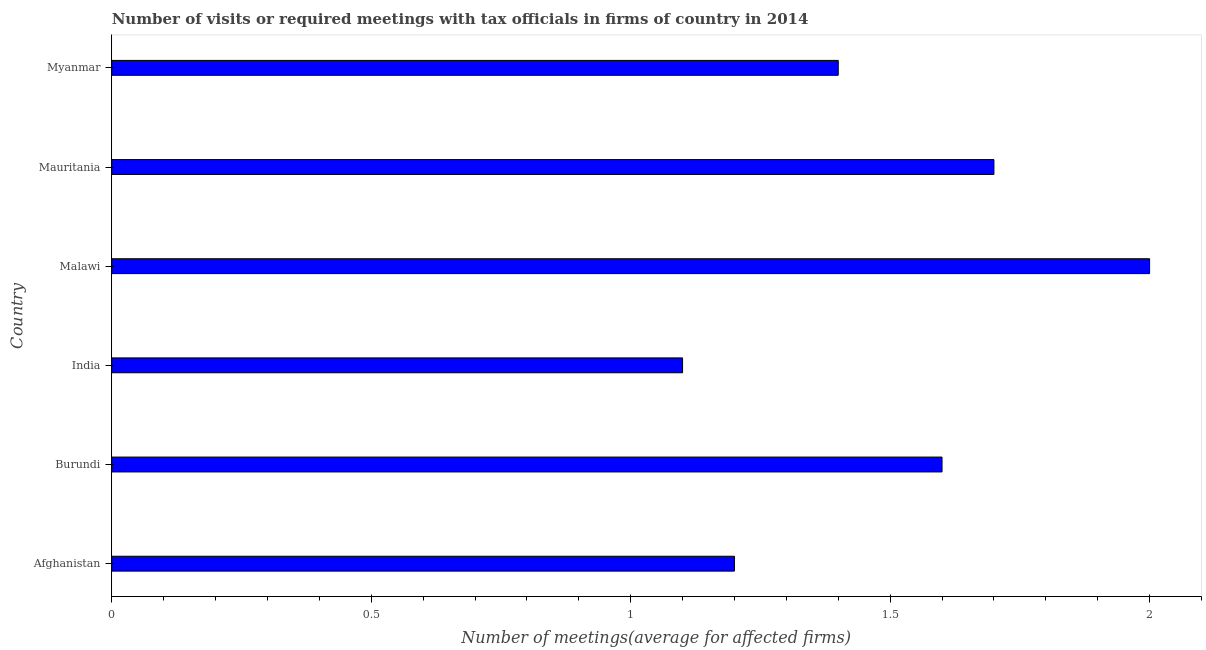Does the graph contain any zero values?
Provide a succinct answer. No. What is the title of the graph?
Your response must be concise. Number of visits or required meetings with tax officials in firms of country in 2014. What is the label or title of the X-axis?
Give a very brief answer. Number of meetings(average for affected firms). What is the label or title of the Y-axis?
Make the answer very short. Country. Across all countries, what is the maximum number of required meetings with tax officials?
Your answer should be compact. 2. Across all countries, what is the minimum number of required meetings with tax officials?
Make the answer very short. 1.1. In which country was the number of required meetings with tax officials maximum?
Provide a short and direct response. Malawi. In which country was the number of required meetings with tax officials minimum?
Provide a succinct answer. India. What is the average number of required meetings with tax officials per country?
Offer a very short reply. 1.5. Is the sum of the number of required meetings with tax officials in Afghanistan and Burundi greater than the maximum number of required meetings with tax officials across all countries?
Your answer should be very brief. Yes. What is the difference between the highest and the lowest number of required meetings with tax officials?
Make the answer very short. 0.9. In how many countries, is the number of required meetings with tax officials greater than the average number of required meetings with tax officials taken over all countries?
Your answer should be very brief. 3. How many countries are there in the graph?
Give a very brief answer. 6. What is the difference between two consecutive major ticks on the X-axis?
Offer a terse response. 0.5. What is the Number of meetings(average for affected firms) in India?
Keep it short and to the point. 1.1. What is the Number of meetings(average for affected firms) in Malawi?
Keep it short and to the point. 2. What is the Number of meetings(average for affected firms) in Mauritania?
Your answer should be very brief. 1.7. What is the difference between the Number of meetings(average for affected firms) in Afghanistan and Burundi?
Ensure brevity in your answer.  -0.4. What is the difference between the Number of meetings(average for affected firms) in Afghanistan and India?
Keep it short and to the point. 0.1. What is the difference between the Number of meetings(average for affected firms) in Afghanistan and Myanmar?
Ensure brevity in your answer.  -0.2. What is the difference between the Number of meetings(average for affected firms) in Burundi and India?
Offer a very short reply. 0.5. What is the difference between the Number of meetings(average for affected firms) in Burundi and Mauritania?
Ensure brevity in your answer.  -0.1. What is the difference between the Number of meetings(average for affected firms) in India and Malawi?
Your response must be concise. -0.9. What is the difference between the Number of meetings(average for affected firms) in Malawi and Mauritania?
Make the answer very short. 0.3. What is the difference between the Number of meetings(average for affected firms) in Malawi and Myanmar?
Give a very brief answer. 0.6. What is the difference between the Number of meetings(average for affected firms) in Mauritania and Myanmar?
Provide a short and direct response. 0.3. What is the ratio of the Number of meetings(average for affected firms) in Afghanistan to that in India?
Your answer should be compact. 1.09. What is the ratio of the Number of meetings(average for affected firms) in Afghanistan to that in Mauritania?
Provide a short and direct response. 0.71. What is the ratio of the Number of meetings(average for affected firms) in Afghanistan to that in Myanmar?
Offer a terse response. 0.86. What is the ratio of the Number of meetings(average for affected firms) in Burundi to that in India?
Provide a succinct answer. 1.46. What is the ratio of the Number of meetings(average for affected firms) in Burundi to that in Mauritania?
Your answer should be compact. 0.94. What is the ratio of the Number of meetings(average for affected firms) in Burundi to that in Myanmar?
Ensure brevity in your answer.  1.14. What is the ratio of the Number of meetings(average for affected firms) in India to that in Malawi?
Your answer should be compact. 0.55. What is the ratio of the Number of meetings(average for affected firms) in India to that in Mauritania?
Offer a terse response. 0.65. What is the ratio of the Number of meetings(average for affected firms) in India to that in Myanmar?
Provide a short and direct response. 0.79. What is the ratio of the Number of meetings(average for affected firms) in Malawi to that in Mauritania?
Your response must be concise. 1.18. What is the ratio of the Number of meetings(average for affected firms) in Malawi to that in Myanmar?
Make the answer very short. 1.43. What is the ratio of the Number of meetings(average for affected firms) in Mauritania to that in Myanmar?
Keep it short and to the point. 1.21. 